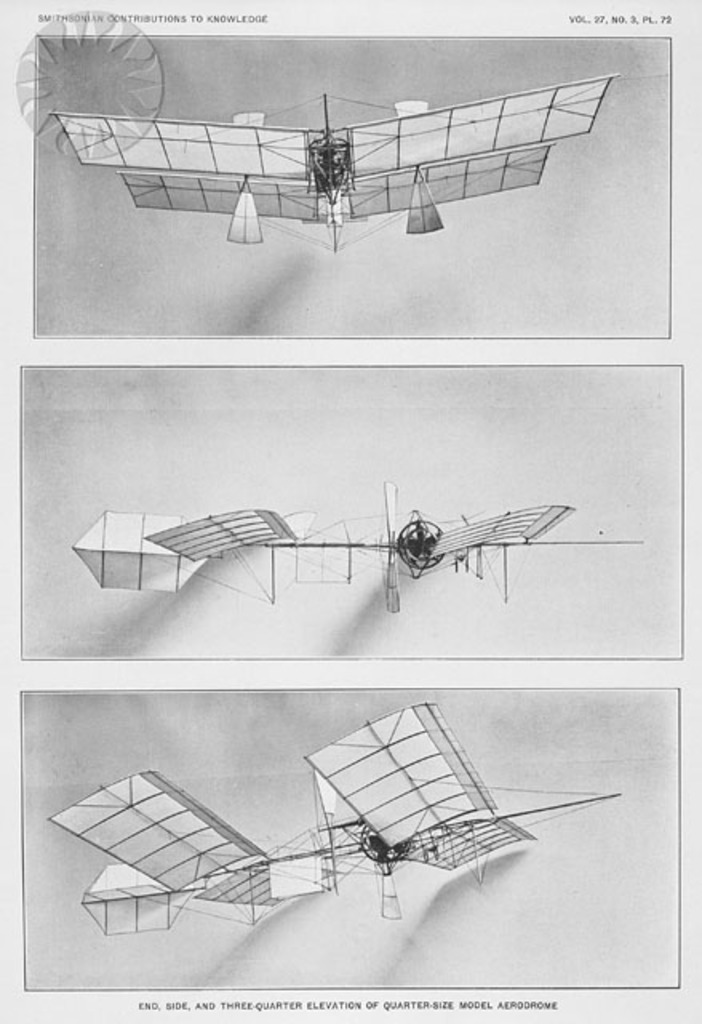What are the distinctive features of the airplane model shown in the image? The model aerodrome in the image includes distinctive features such as a multi-wing design with both upper and lower wings connected by numerous vertical struts, triangular support structures at the rear, and a centralized propeller mechanism. This design was typical of early aviation experiments where stability and lift were key areas of focus. 